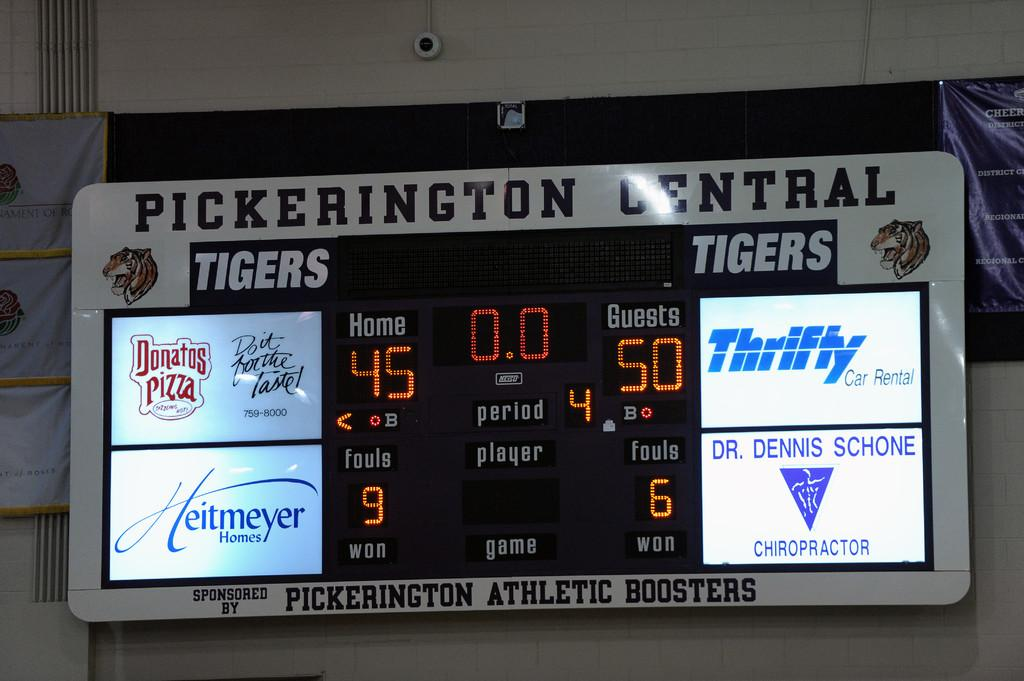<image>
Summarize the visual content of the image. A scoreboard hanging on the wall that shows a score of 45 to 50. 